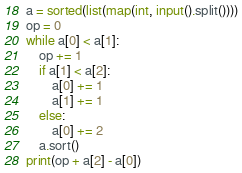Convert code to text. <code><loc_0><loc_0><loc_500><loc_500><_Python_>a = sorted(list(map(int, input().split())))
op = 0
while a[0] < a[1]:
    op += 1
    if a[1] < a[2]:
        a[0] += 1
        a[1] += 1
    else:
        a[0] += 2
    a.sort()
print(op + a[2] - a[0])
</code> 